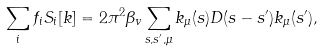Convert formula to latex. <formula><loc_0><loc_0><loc_500><loc_500>\sum _ { i } f _ { i } S _ { i } [ k ] = 2 \pi ^ { 2 } \beta _ { v } \sum _ { s , s ^ { \prime } , \mu } k _ { \mu } ( s ) D ( s - s ^ { \prime } ) k _ { \mu } ( s ^ { \prime } ) ,</formula> 